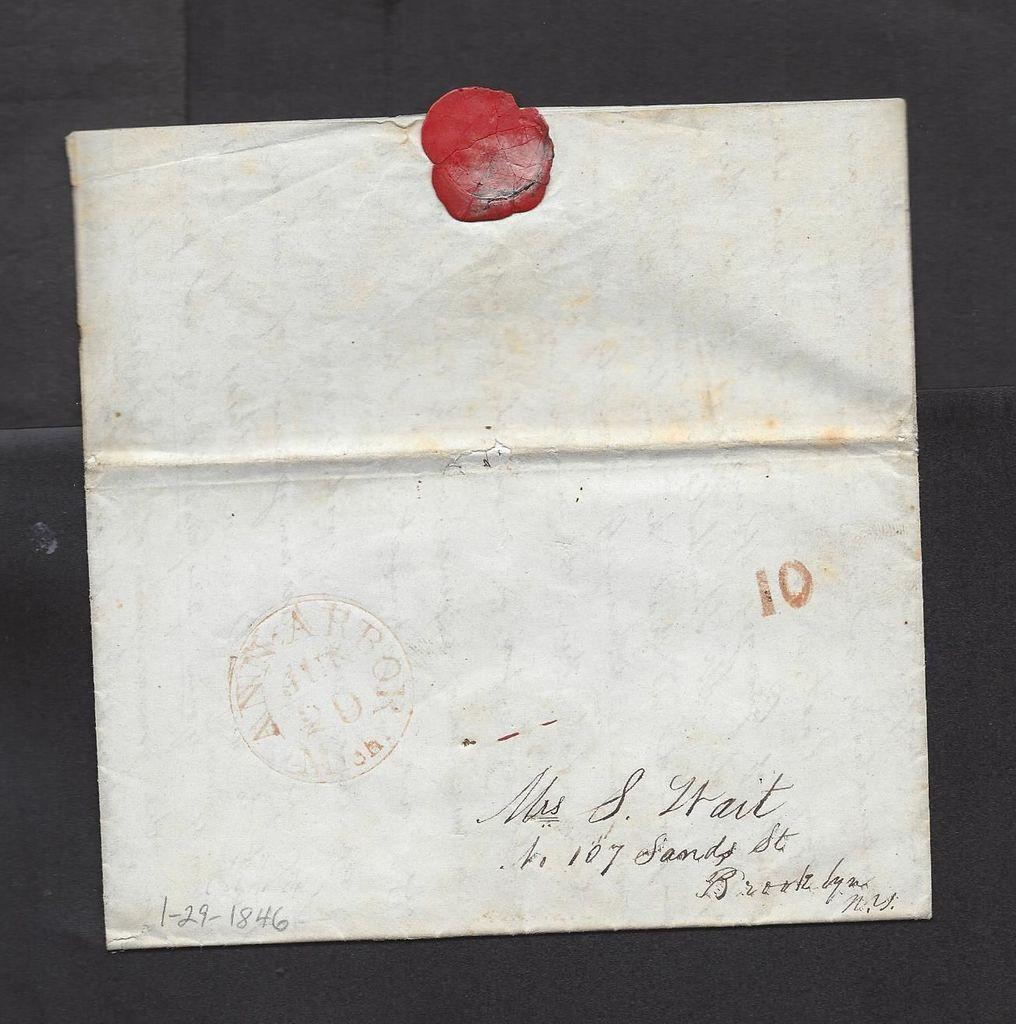<image>
Present a compact description of the photo's key features. A letter dated with 1-29-1846 shows a red wax stamp on top 